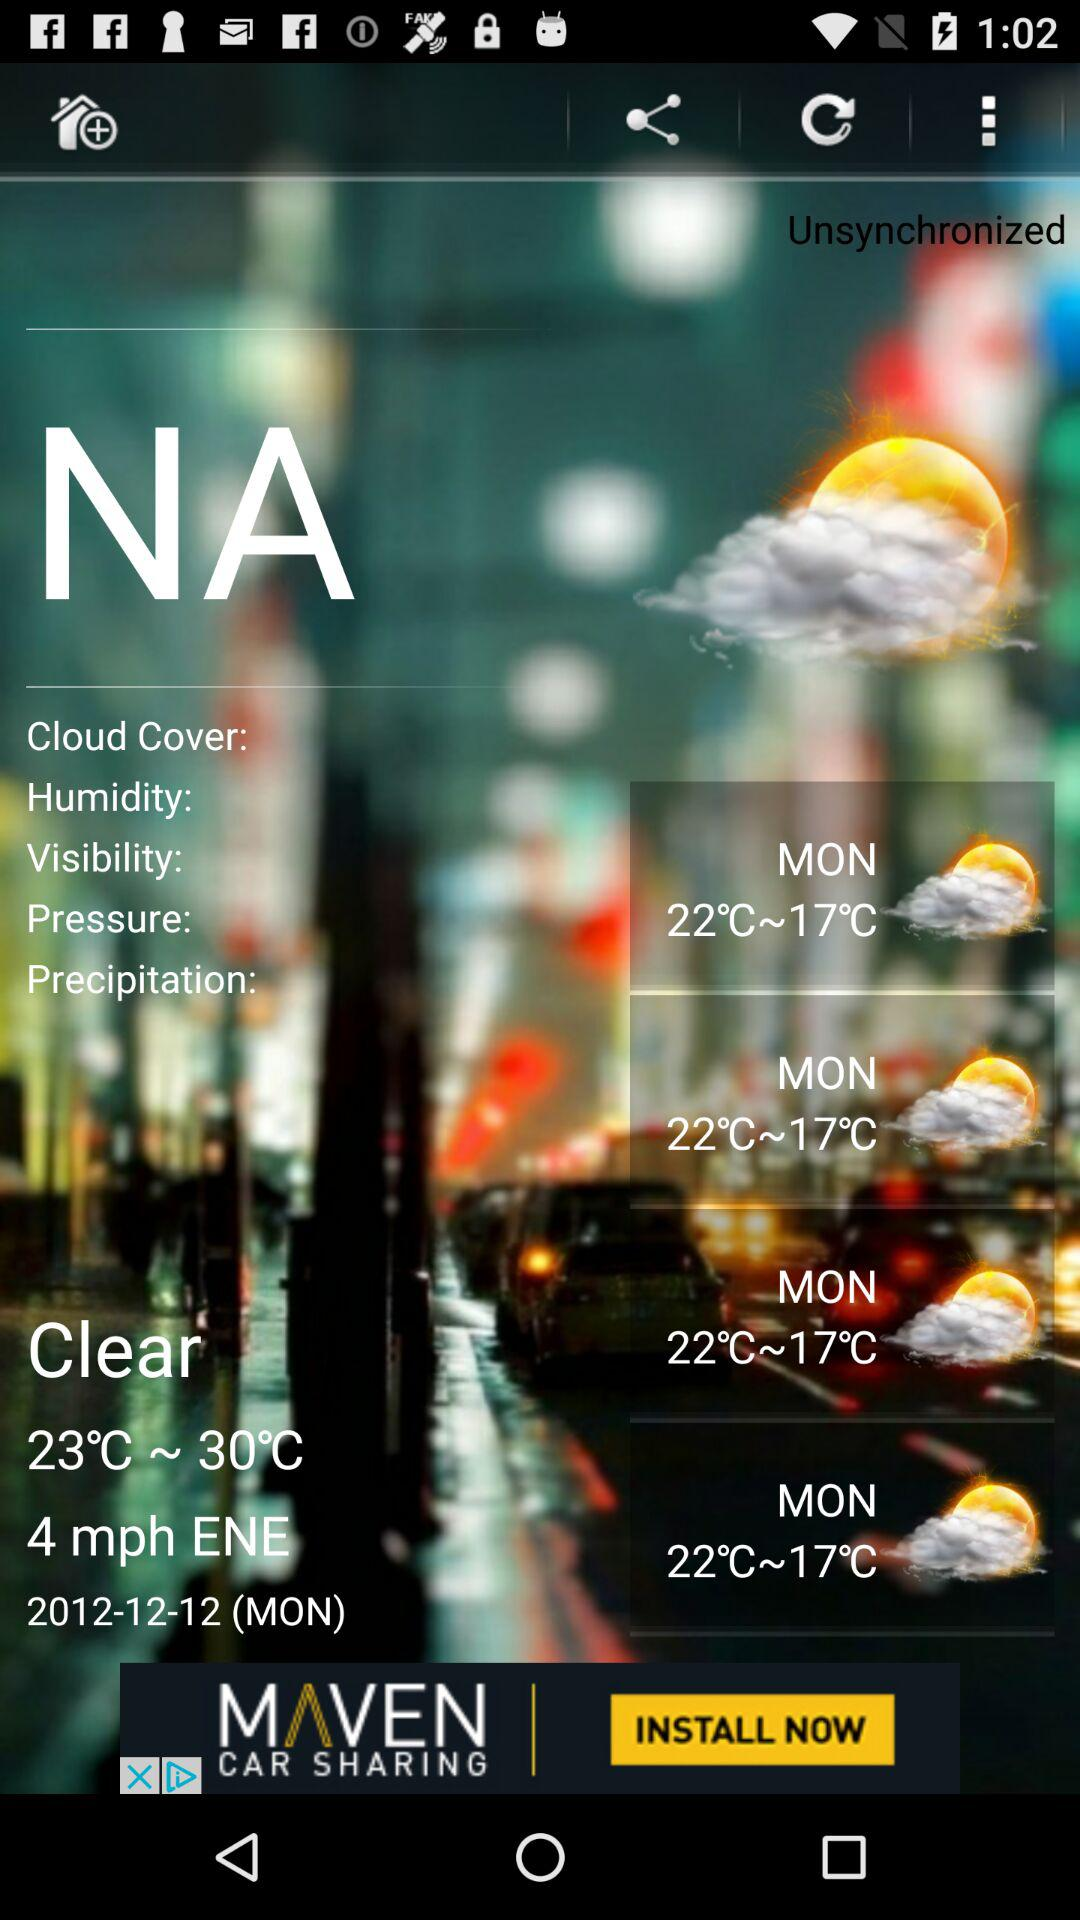What is the wind speed? The wind speed is 4 mph. 